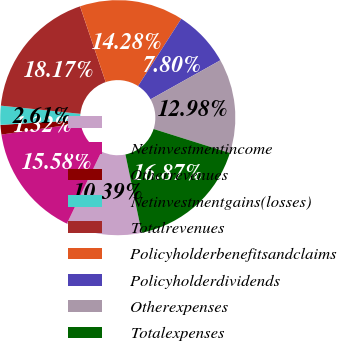<chart> <loc_0><loc_0><loc_500><loc_500><pie_chart><ecel><fcel>Netinvestmentincome<fcel>Otherrevenues<fcel>Netinvestmentgains(losses)<fcel>Totalrevenues<fcel>Policyholderbenefitsandclaims<fcel>Policyholderdividends<fcel>Otherexpenses<fcel>Totalexpenses<nl><fcel>10.39%<fcel>15.58%<fcel>1.32%<fcel>2.61%<fcel>18.17%<fcel>14.28%<fcel>7.8%<fcel>12.98%<fcel>16.87%<nl></chart> 